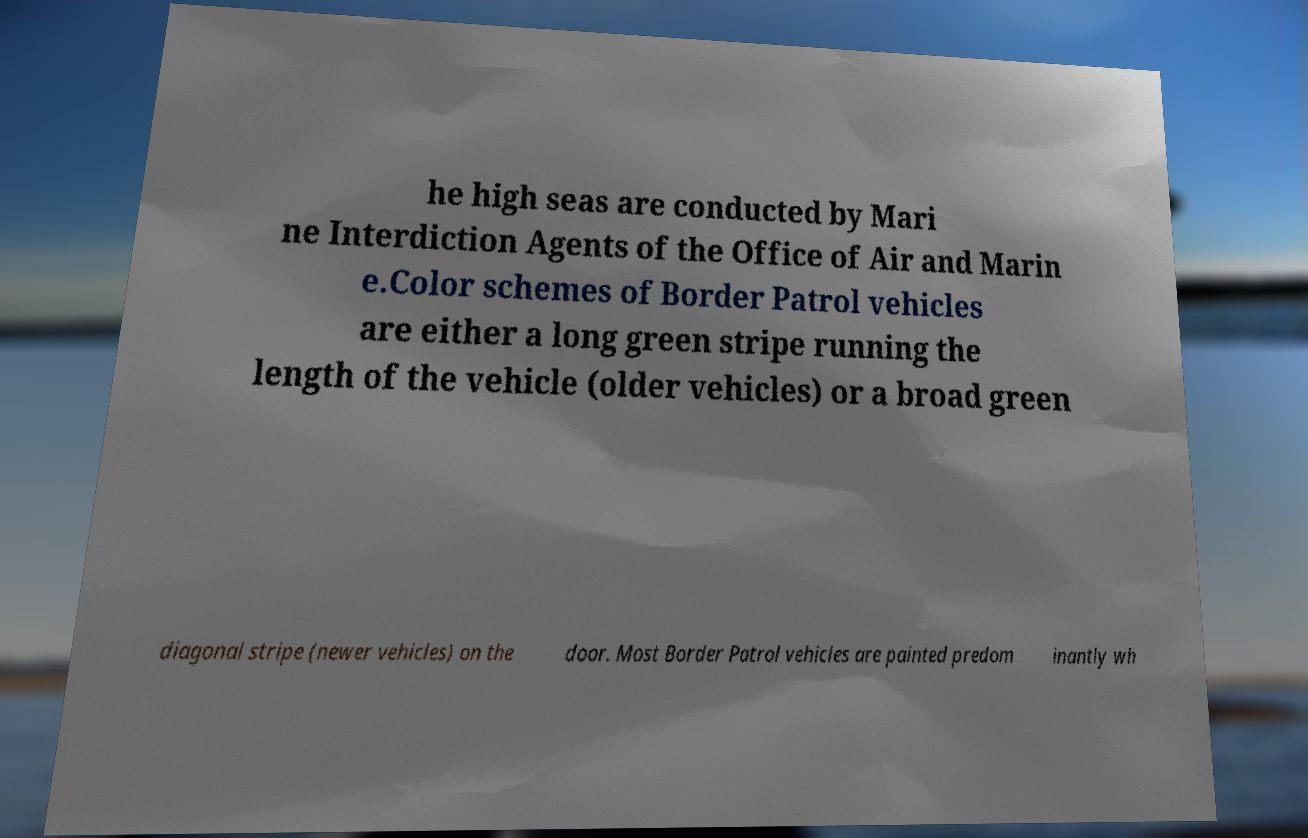I need the written content from this picture converted into text. Can you do that? he high seas are conducted by Mari ne Interdiction Agents of the Office of Air and Marin e.Color schemes of Border Patrol vehicles are either a long green stripe running the length of the vehicle (older vehicles) or a broad green diagonal stripe (newer vehicles) on the door. Most Border Patrol vehicles are painted predom inantly wh 